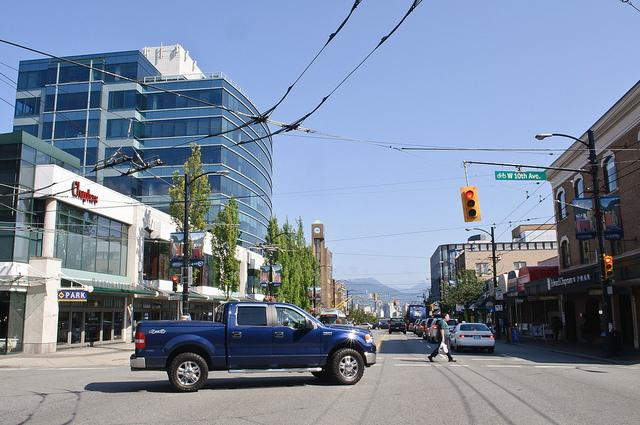What is the make of the blue pickup truck? Please explain your reasoning. ford. Ford makes the blue pickup truck. 